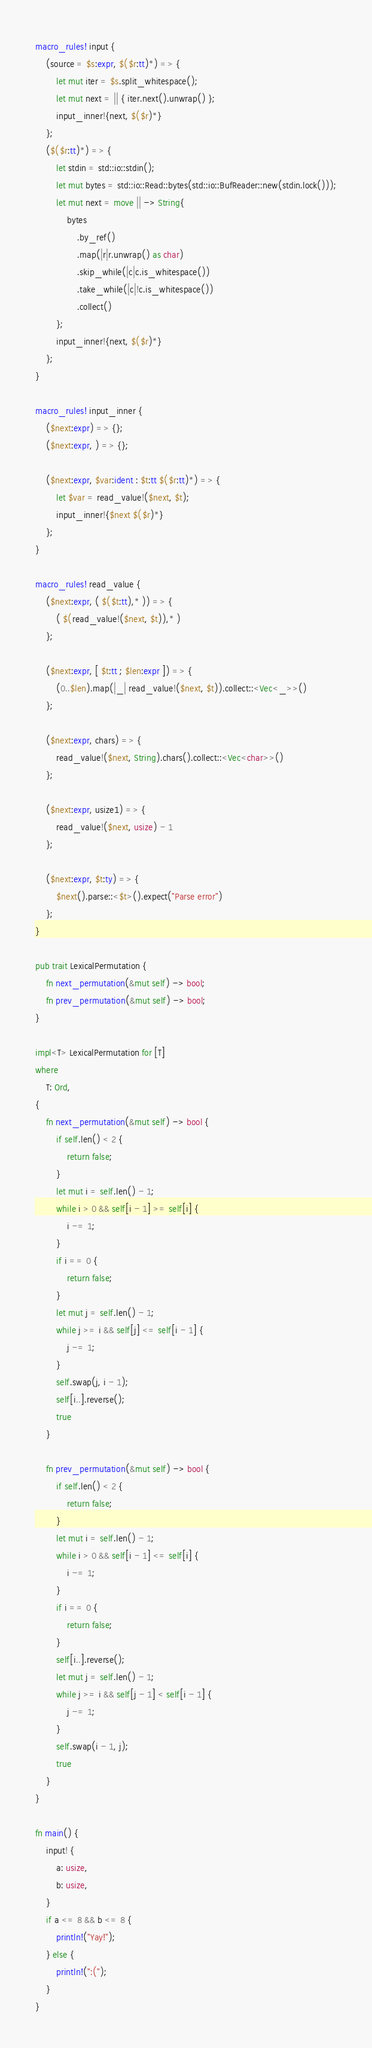<code> <loc_0><loc_0><loc_500><loc_500><_Rust_>macro_rules! input {
    (source = $s:expr, $($r:tt)*) => {
        let mut iter = $s.split_whitespace();
        let mut next = || { iter.next().unwrap() };
        input_inner!{next, $($r)*}
    };
    ($($r:tt)*) => {
        let stdin = std::io::stdin();
        let mut bytes = std::io::Read::bytes(std::io::BufReader::new(stdin.lock()));
        let mut next = move || -> String{
            bytes
                .by_ref()
                .map(|r|r.unwrap() as char)
                .skip_while(|c|c.is_whitespace())
                .take_while(|c|!c.is_whitespace())
                .collect()
        };
        input_inner!{next, $($r)*}
    };
}

macro_rules! input_inner {
    ($next:expr) => {};
    ($next:expr, ) => {};

    ($next:expr, $var:ident : $t:tt $($r:tt)*) => {
        let $var = read_value!($next, $t);
        input_inner!{$next $($r)*}
    };
}

macro_rules! read_value {
    ($next:expr, ( $($t:tt),* )) => {
        ( $(read_value!($next, $t)),* )
    };

    ($next:expr, [ $t:tt ; $len:expr ]) => {
        (0..$len).map(|_| read_value!($next, $t)).collect::<Vec<_>>()
    };

    ($next:expr, chars) => {
        read_value!($next, String).chars().collect::<Vec<char>>()
    };

    ($next:expr, usize1) => {
        read_value!($next, usize) - 1
    };

    ($next:expr, $t:ty) => {
        $next().parse::<$t>().expect("Parse error")
    };
}

pub trait LexicalPermutation {
    fn next_permutation(&mut self) -> bool;
    fn prev_permutation(&mut self) -> bool;
}

impl<T> LexicalPermutation for [T]
where
    T: Ord,
{
    fn next_permutation(&mut self) -> bool {
        if self.len() < 2 {
            return false;
        }
        let mut i = self.len() - 1;
        while i > 0 && self[i - 1] >= self[i] {
            i -= 1;
        }
        if i == 0 {
            return false;
        }
        let mut j = self.len() - 1;
        while j >= i && self[j] <= self[i - 1] {
            j -= 1;
        }
        self.swap(j, i - 1);
        self[i..].reverse();
        true
    }

    fn prev_permutation(&mut self) -> bool {
        if self.len() < 2 {
            return false;
        }
        let mut i = self.len() - 1;
        while i > 0 && self[i - 1] <= self[i] {
            i -= 1;
        }
        if i == 0 {
            return false;
        }
        self[i..].reverse();
        let mut j = self.len() - 1;
        while j >= i && self[j - 1] < self[i - 1] {
            j -= 1;
        }
        self.swap(i - 1, j);
        true
    }
}

fn main() {
    input! {
        a: usize,
        b: usize,
    }
    if a <= 8 && b <= 8 {
        println!("Yay!");
    } else {
        println!(":(");
    }
}
</code> 